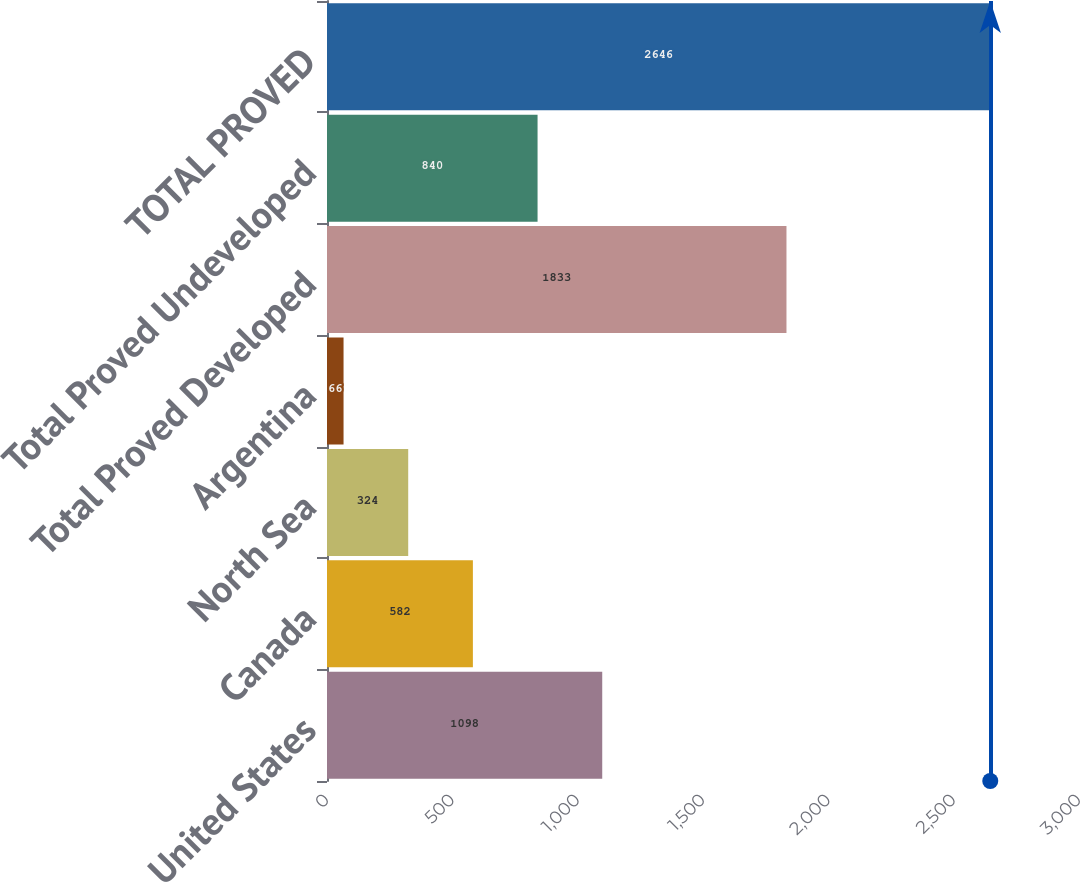Convert chart to OTSL. <chart><loc_0><loc_0><loc_500><loc_500><bar_chart><fcel>United States<fcel>Canada<fcel>North Sea<fcel>Argentina<fcel>Total Proved Developed<fcel>Total Proved Undeveloped<fcel>TOTAL PROVED<nl><fcel>1098<fcel>582<fcel>324<fcel>66<fcel>1833<fcel>840<fcel>2646<nl></chart> 